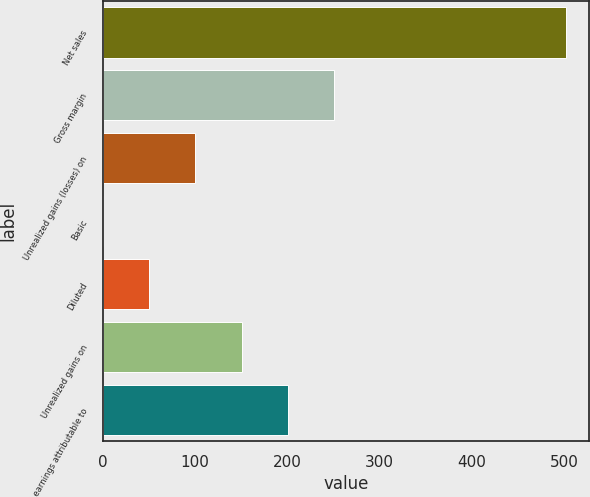<chart> <loc_0><loc_0><loc_500><loc_500><bar_chart><fcel>Net sales<fcel>Gross margin<fcel>Unrealized gains (losses) on<fcel>Basic<fcel>Diluted<fcel>Unrealized gains on<fcel>Net earnings attributable to<nl><fcel>502.4<fcel>251.24<fcel>100.55<fcel>0.09<fcel>50.32<fcel>150.78<fcel>201.01<nl></chart> 